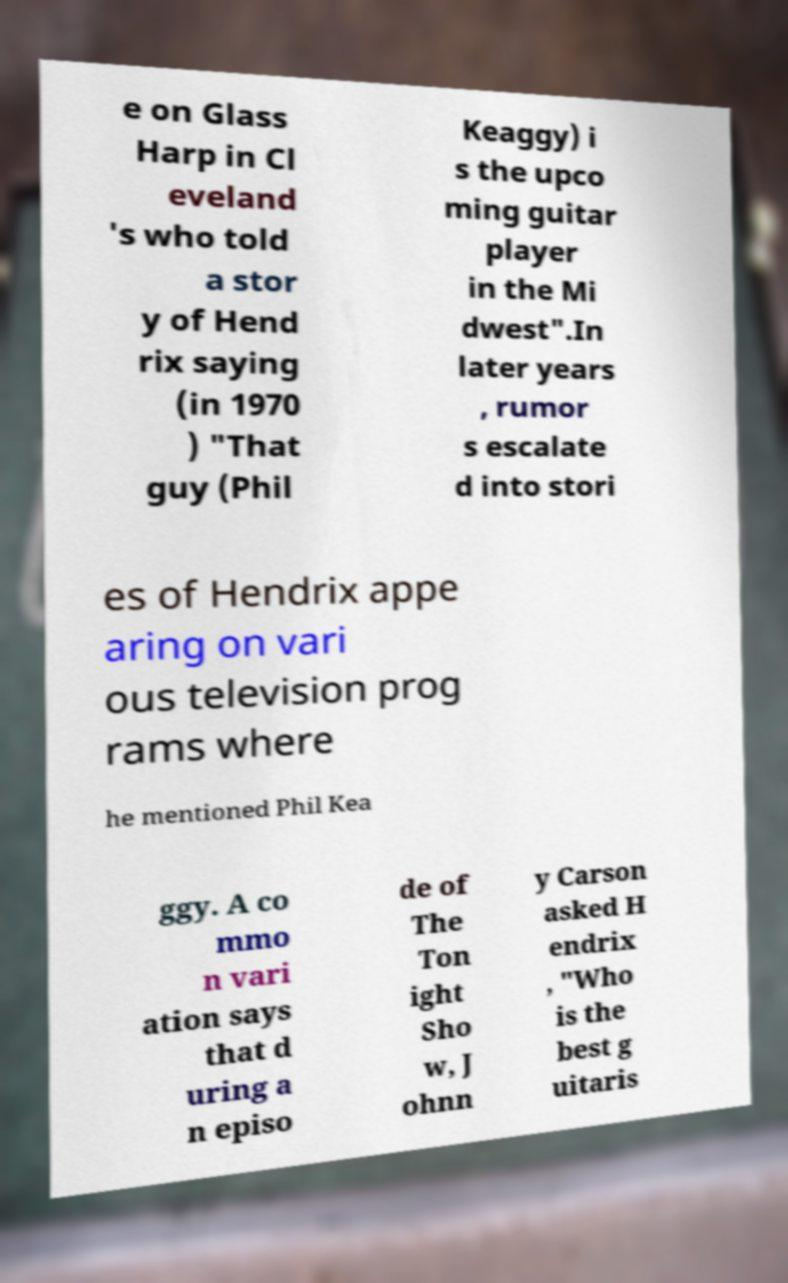Can you read and provide the text displayed in the image?This photo seems to have some interesting text. Can you extract and type it out for me? e on Glass Harp in Cl eveland 's who told a stor y of Hend rix saying (in 1970 ) "That guy (Phil Keaggy) i s the upco ming guitar player in the Mi dwest".In later years , rumor s escalate d into stori es of Hendrix appe aring on vari ous television prog rams where he mentioned Phil Kea ggy. A co mmo n vari ation says that d uring a n episo de of The Ton ight Sho w, J ohnn y Carson asked H endrix , "Who is the best g uitaris 